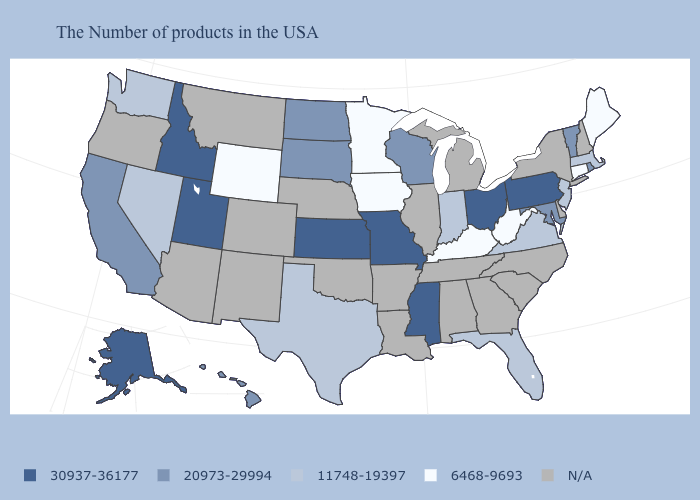What is the value of Nebraska?
Quick response, please. N/A. Which states have the lowest value in the West?
Short answer required. Wyoming. What is the highest value in the West ?
Keep it brief. 30937-36177. Does Pennsylvania have the highest value in the USA?
Answer briefly. Yes. What is the value of Maryland?
Keep it brief. 20973-29994. Name the states that have a value in the range 6468-9693?
Keep it brief. Maine, Connecticut, West Virginia, Kentucky, Minnesota, Iowa, Wyoming. How many symbols are there in the legend?
Answer briefly. 5. Does Mississippi have the lowest value in the USA?
Quick response, please. No. Name the states that have a value in the range 11748-19397?
Give a very brief answer. Massachusetts, New Jersey, Virginia, Florida, Indiana, Texas, Nevada, Washington. What is the highest value in the South ?
Give a very brief answer. 30937-36177. Name the states that have a value in the range 6468-9693?
Quick response, please. Maine, Connecticut, West Virginia, Kentucky, Minnesota, Iowa, Wyoming. Name the states that have a value in the range 11748-19397?
Concise answer only. Massachusetts, New Jersey, Virginia, Florida, Indiana, Texas, Nevada, Washington. What is the value of Maryland?
Be succinct. 20973-29994. Among the states that border Montana , which have the highest value?
Keep it brief. Idaho. Among the states that border Louisiana , does Texas have the lowest value?
Answer briefly. Yes. 